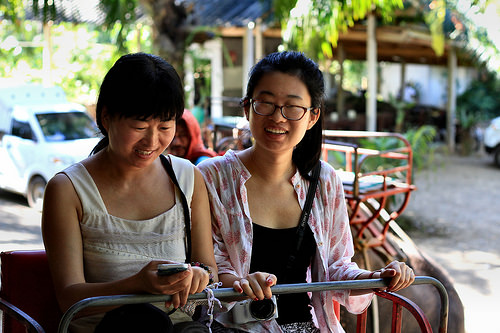<image>
Is there a girl on the seat? Yes. Looking at the image, I can see the girl is positioned on top of the seat, with the seat providing support. 